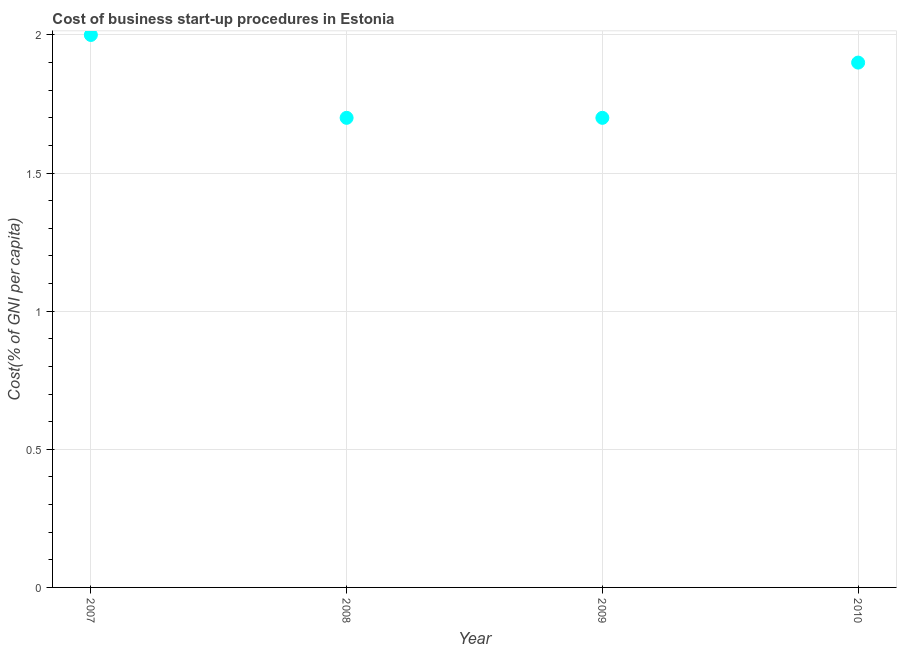What is the cost of business startup procedures in 2008?
Your response must be concise. 1.7. Across all years, what is the minimum cost of business startup procedures?
Ensure brevity in your answer.  1.7. In which year was the cost of business startup procedures minimum?
Ensure brevity in your answer.  2008. What is the sum of the cost of business startup procedures?
Your answer should be compact. 7.3. What is the difference between the cost of business startup procedures in 2007 and 2008?
Make the answer very short. 0.3. What is the average cost of business startup procedures per year?
Your answer should be very brief. 1.83. What is the median cost of business startup procedures?
Ensure brevity in your answer.  1.8. In how many years, is the cost of business startup procedures greater than 0.9 %?
Make the answer very short. 4. Do a majority of the years between 2007 and 2010 (inclusive) have cost of business startup procedures greater than 1.3 %?
Your response must be concise. Yes. Is the cost of business startup procedures in 2007 less than that in 2008?
Your answer should be very brief. No. What is the difference between the highest and the second highest cost of business startup procedures?
Keep it short and to the point. 0.1. Is the sum of the cost of business startup procedures in 2008 and 2009 greater than the maximum cost of business startup procedures across all years?
Offer a terse response. Yes. What is the difference between the highest and the lowest cost of business startup procedures?
Keep it short and to the point. 0.3. How many dotlines are there?
Offer a terse response. 1. Does the graph contain any zero values?
Provide a short and direct response. No. Does the graph contain grids?
Your response must be concise. Yes. What is the title of the graph?
Provide a succinct answer. Cost of business start-up procedures in Estonia. What is the label or title of the Y-axis?
Your answer should be compact. Cost(% of GNI per capita). What is the Cost(% of GNI per capita) in 2007?
Offer a very short reply. 2. What is the difference between the Cost(% of GNI per capita) in 2007 and 2009?
Your answer should be compact. 0.3. What is the difference between the Cost(% of GNI per capita) in 2008 and 2009?
Provide a succinct answer. 0. What is the difference between the Cost(% of GNI per capita) in 2009 and 2010?
Make the answer very short. -0.2. What is the ratio of the Cost(% of GNI per capita) in 2007 to that in 2008?
Provide a short and direct response. 1.18. What is the ratio of the Cost(% of GNI per capita) in 2007 to that in 2009?
Offer a very short reply. 1.18. What is the ratio of the Cost(% of GNI per capita) in 2007 to that in 2010?
Your answer should be compact. 1.05. What is the ratio of the Cost(% of GNI per capita) in 2008 to that in 2009?
Ensure brevity in your answer.  1. What is the ratio of the Cost(% of GNI per capita) in 2008 to that in 2010?
Your response must be concise. 0.9. What is the ratio of the Cost(% of GNI per capita) in 2009 to that in 2010?
Give a very brief answer. 0.9. 